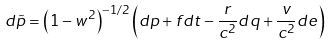Convert formula to latex. <formula><loc_0><loc_0><loc_500><loc_500>d \tilde { p } = { \left ( 1 - w ^ { 2 } \right ) } ^ { - 1 / 2 } \left ( d p + f d t - \frac { r } { c ^ { 2 } } d q + \frac { v } { c ^ { 2 } } d e \right )</formula> 